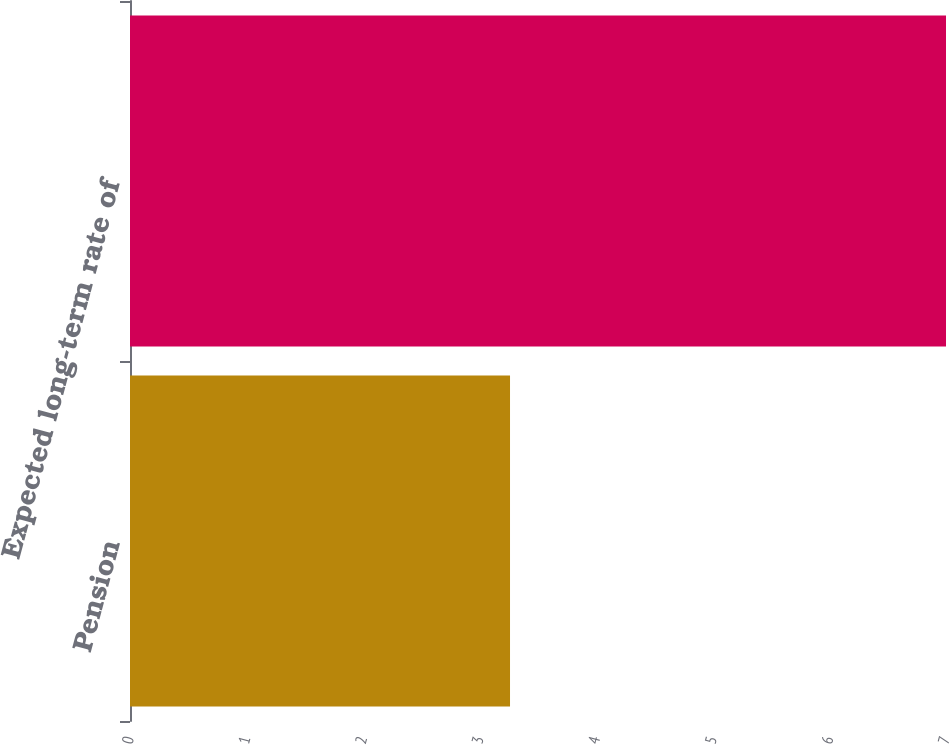Convert chart. <chart><loc_0><loc_0><loc_500><loc_500><bar_chart><fcel>Pension<fcel>Expected long-term rate of<nl><fcel>3.26<fcel>7<nl></chart> 